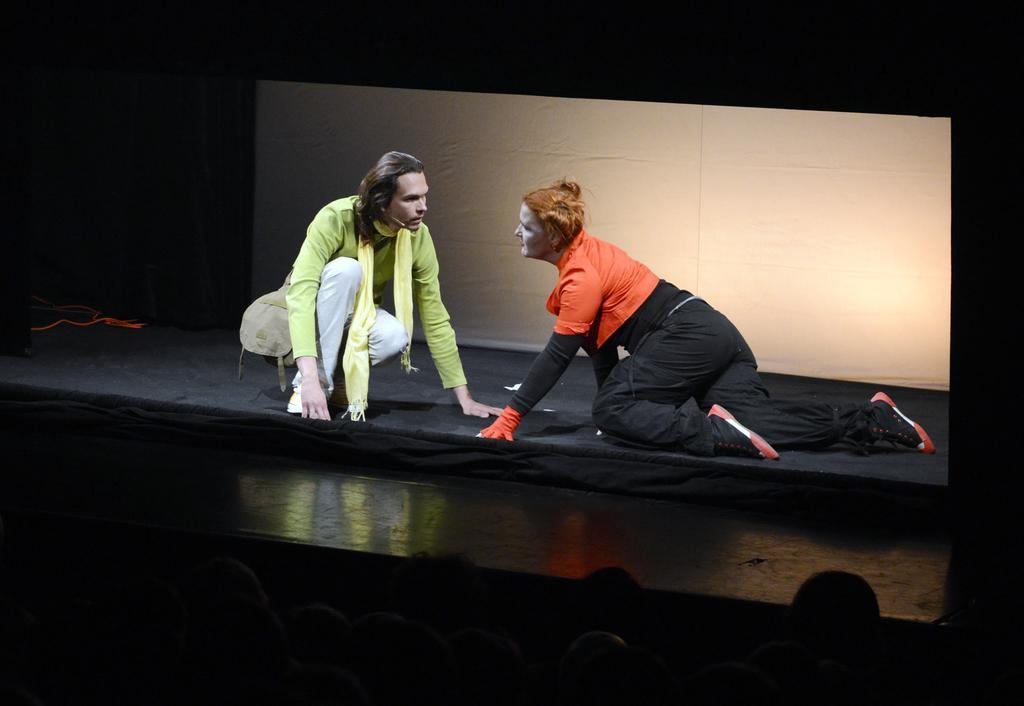Describe this image in one or two sentences. In the center of the image we can see two people are wearing costume and acting on the stage. In the background of the image we can see the cloth, board. At the bottom of the image we can see some people are sitting. 